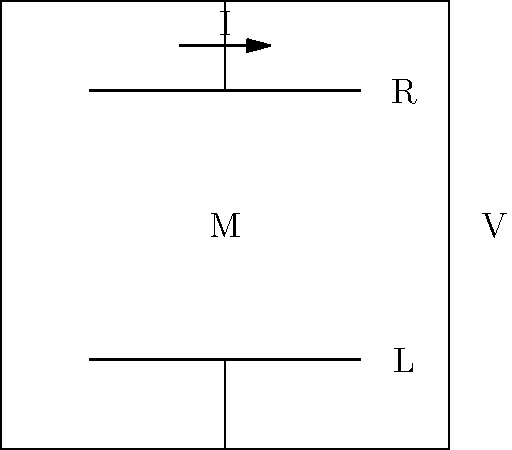As a travel agent promoting rural tourism, you're visiting a farm that wants to optimize its irrigation system's energy efficiency. The farmer shows you a simplified circuit diagram of their pump system, as shown above. If the voltage source (V) is 120V, the resistance (R) is 10Ω, and the inductance (L) is 0.5H, what would be the optimal frequency (in Hz) to operate this system for maximum power transfer to the motor (M)? To find the optimal frequency for maximum power transfer, we need to follow these steps:

1. Recognize that this is an RL circuit with a motor load.

2. For maximum power transfer, the impedance of the load should match the impedance of the source.

3. The total impedance (Z) of an RL circuit is given by:
   $$Z = \sqrt{R^2 + (2\pi fL)^2}$$
   where f is the frequency, R is the resistance, and L is the inductance.

4. For maximum power transfer, we want:
   $$R = 2\pi fL$$

5. Rearranging this equation to solve for f:
   $$f = \frac{R}{2\pi L}$$

6. Substituting the given values:
   $$f = \frac{10}{2\pi(0.5)} = \frac{10}{\pi} \approx 3.18 \text{ Hz}$$

7. Round to the nearest whole number for practical application.
Answer: 3 Hz 